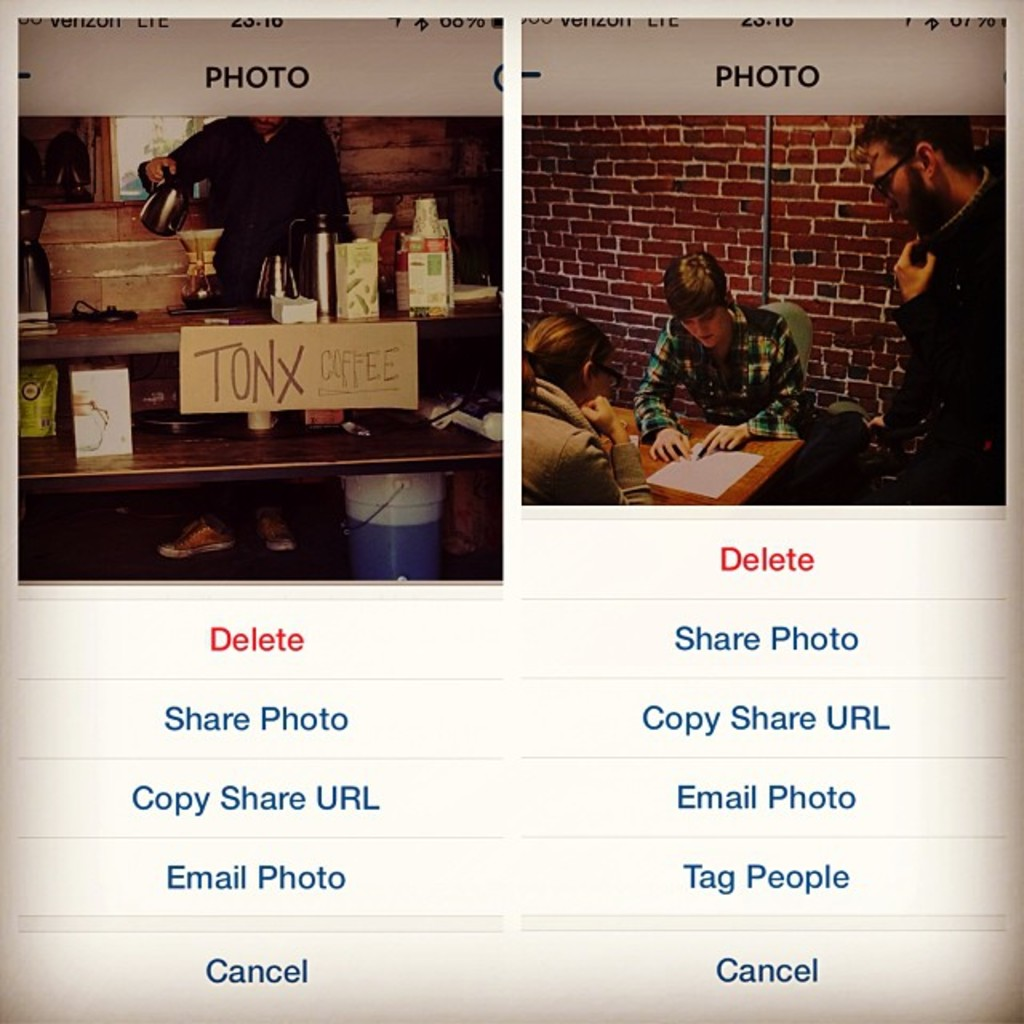Can you tell me more about the setting of the coffee station? The coffee station is set against a rustic brick wall, giving it a warm, inviting atmosphere typical of cozy cafés. The presence of a kettle and various canisters suggests it's equipped to serve freshly made coffee and possibly tea. The informal setup with a handwritten cardboard sign also points to a relaxed, possibly artisanal approach to coffee selling, appealing to coffee enthusiasts or casual visitors alike. 